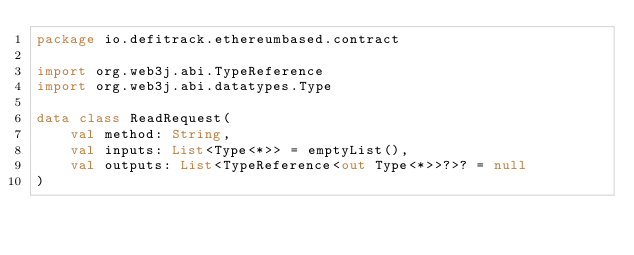<code> <loc_0><loc_0><loc_500><loc_500><_Kotlin_>package io.defitrack.ethereumbased.contract

import org.web3j.abi.TypeReference
import org.web3j.abi.datatypes.Type

data class ReadRequest(
    val method: String,
    val inputs: List<Type<*>> = emptyList(),
    val outputs: List<TypeReference<out Type<*>>?>? = null
)</code> 